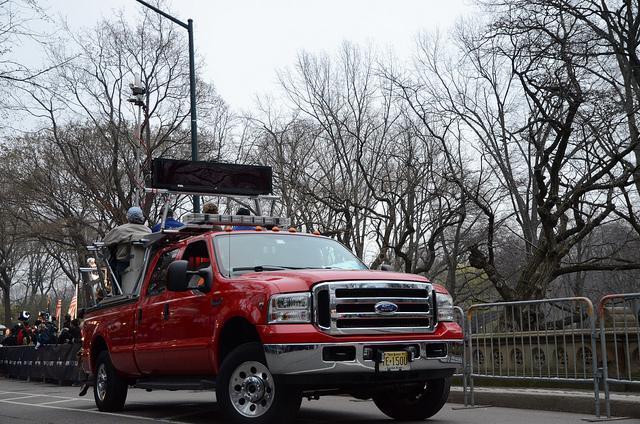How many tarps do you see?
Give a very brief answer. 0. How many traffic lights are visible?
Give a very brief answer. 1. How many orange ropescables are attached to the clock?
Give a very brief answer. 0. 